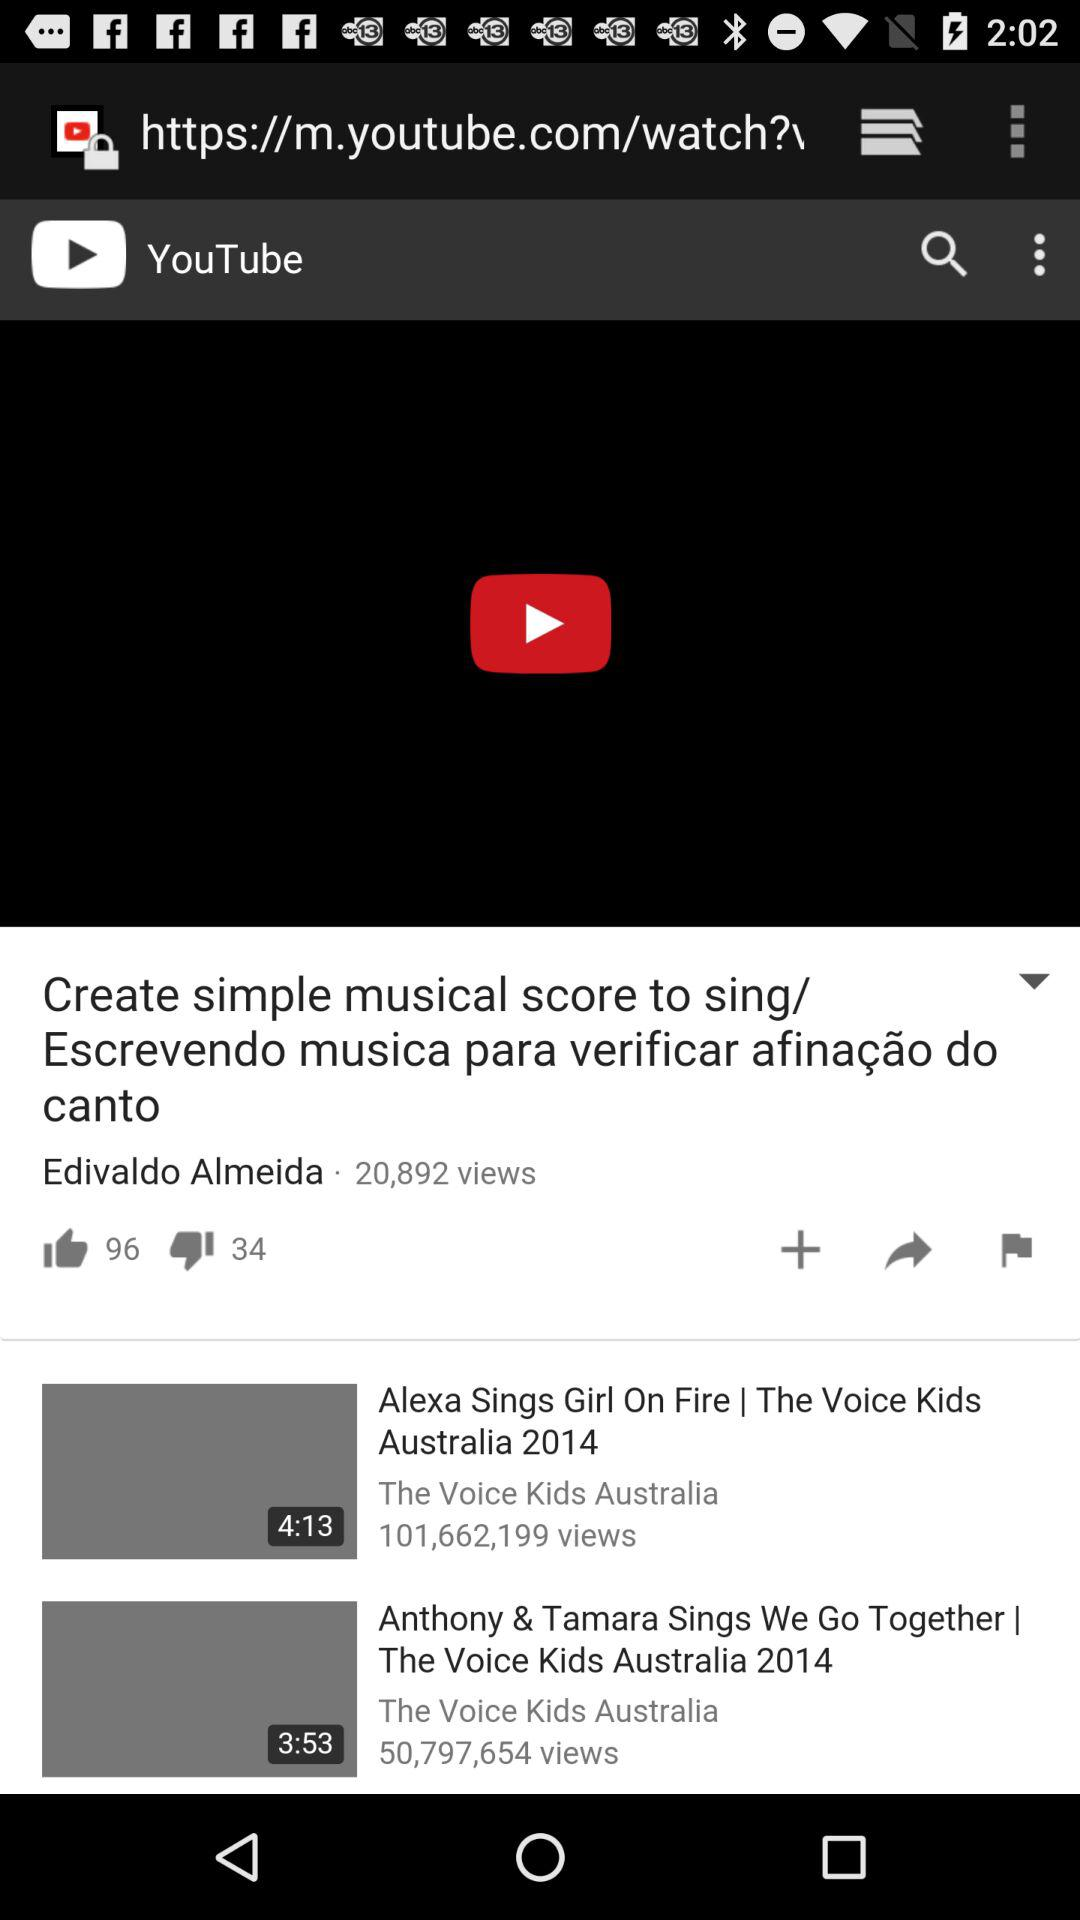Which video has 101,662,199 views? The video "Alexa Sings Girl On Fire | The Voice Kids Australia 2014" has 101,662,199 views. 